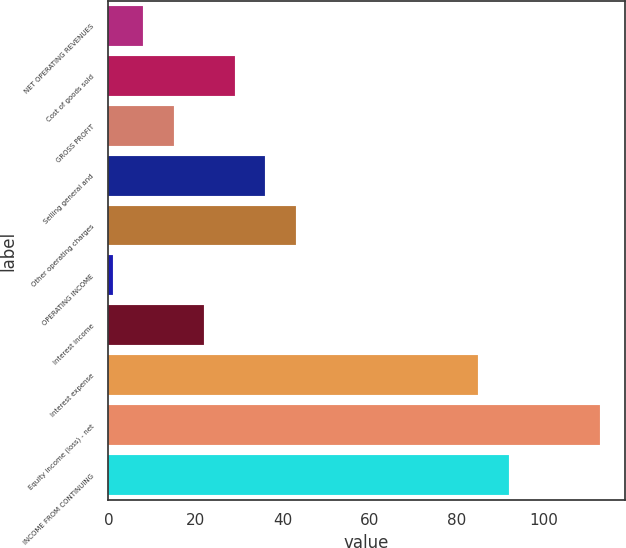Convert chart. <chart><loc_0><loc_0><loc_500><loc_500><bar_chart><fcel>NET OPERATING REVENUES<fcel>Cost of goods sold<fcel>GROSS PROFIT<fcel>Selling general and<fcel>Other operating charges<fcel>OPERATING INCOME<fcel>Interest income<fcel>Interest expense<fcel>Equity income (loss) - net<fcel>INCOME FROM CONTINUING<nl><fcel>8<fcel>29<fcel>15<fcel>36<fcel>43<fcel>1<fcel>22<fcel>85<fcel>113<fcel>92<nl></chart> 